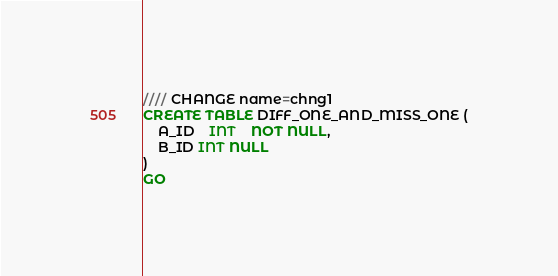<code> <loc_0><loc_0><loc_500><loc_500><_SQL_>//// CHANGE name=chng1
CREATE TABLE DIFF_ONE_AND_MISS_ONE (
	A_ID    INT	NOT NULL,
	B_ID INT NULL
)
GO
</code> 